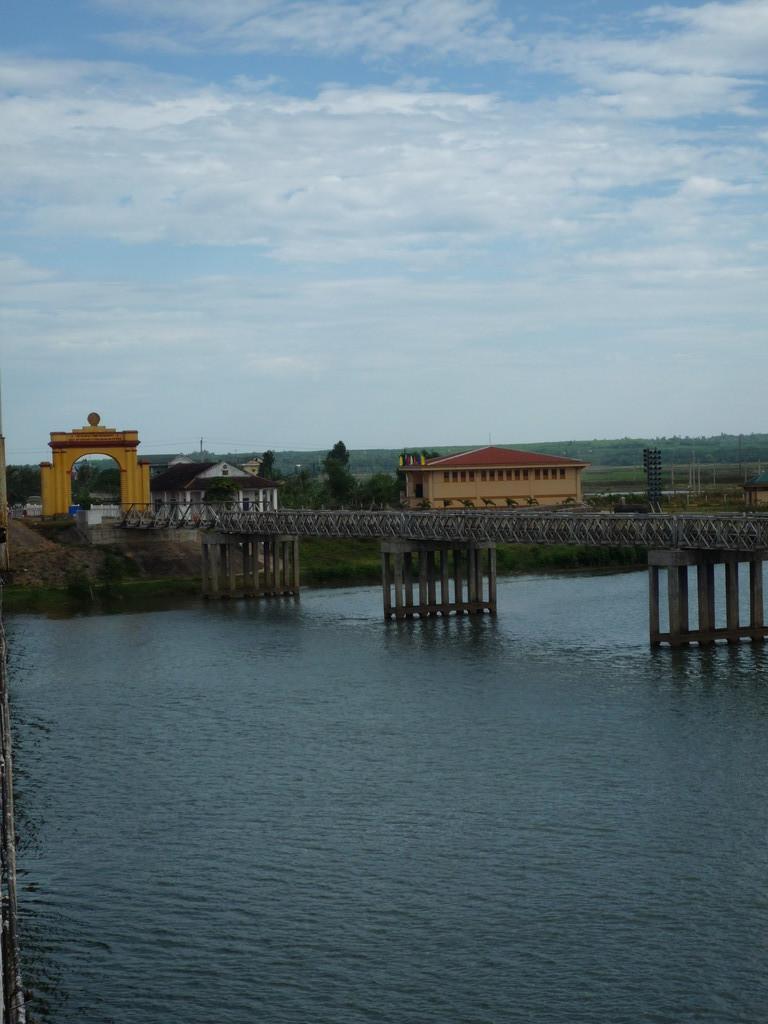In one or two sentences, can you explain what this image depicts? This is completely an outdoor picture. Here we can see a river with fresh water. This is a bridge. This is the building. We can see an arch with golden yellow and brown in colour. On the background of the picture we can see trees. At the top a blue sky with clouds. This is a house. 